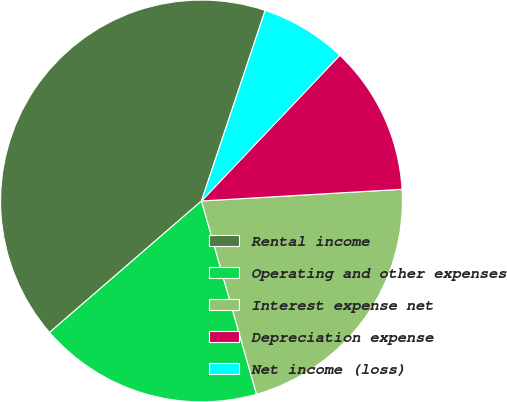Convert chart to OTSL. <chart><loc_0><loc_0><loc_500><loc_500><pie_chart><fcel>Rental income<fcel>Operating and other expenses<fcel>Interest expense net<fcel>Depreciation expense<fcel>Net income (loss)<nl><fcel>41.48%<fcel>18.06%<fcel>21.51%<fcel>11.99%<fcel>6.95%<nl></chart> 